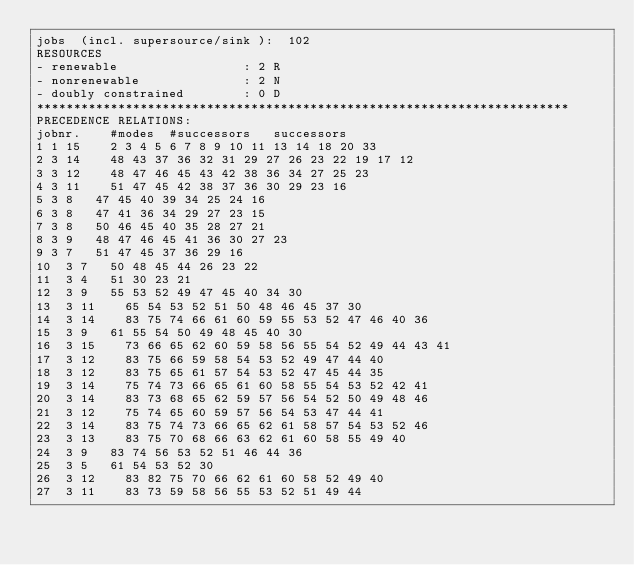<code> <loc_0><loc_0><loc_500><loc_500><_ObjectiveC_>jobs  (incl. supersource/sink ):	102
RESOURCES
- renewable                 : 2 R
- nonrenewable              : 2 N
- doubly constrained        : 0 D
************************************************************************
PRECEDENCE RELATIONS:
jobnr.    #modes  #successors   successors
1	1	15		2 3 4 5 6 7 8 9 10 11 13 14 18 20 33 
2	3	14		48 43 37 36 32 31 29 27 26 23 22 19 17 12 
3	3	12		48 47 46 45 43 42 38 36 34 27 25 23 
4	3	11		51 47 45 42 38 37 36 30 29 23 16 
5	3	8		47 45 40 39 34 25 24 16 
6	3	8		47 41 36 34 29 27 23 15 
7	3	8		50 46 45 40 35 28 27 21 
8	3	9		48 47 46 45 41 36 30 27 23 
9	3	7		51 47 45 37 36 29 16 
10	3	7		50 48 45 44 26 23 22 
11	3	4		51 30 23 21 
12	3	9		55 53 52 49 47 45 40 34 30 
13	3	11		65 54 53 52 51 50 48 46 45 37 30 
14	3	14		83 75 74 66 61 60 59 55 53 52 47 46 40 36 
15	3	9		61 55 54 50 49 48 45 40 30 
16	3	15		73 66 65 62 60 59 58 56 55 54 52 49 44 43 41 
17	3	12		83 75 66 59 58 54 53 52 49 47 44 40 
18	3	12		83 75 65 61 57 54 53 52 47 45 44 35 
19	3	14		75 74 73 66 65 61 60 58 55 54 53 52 42 41 
20	3	14		83 73 68 65 62 59 57 56 54 52 50 49 48 46 
21	3	12		75 74 65 60 59 57 56 54 53 47 44 41 
22	3	14		83 75 74 73 66 65 62 61 58 57 54 53 52 46 
23	3	13		83 75 70 68 66 63 62 61 60 58 55 49 40 
24	3	9		83 74 56 53 52 51 46 44 36 
25	3	5		61 54 53 52 30 
26	3	12		83 82 75 70 66 62 61 60 58 52 49 40 
27	3	11		83 73 59 58 56 55 53 52 51 49 44 </code> 